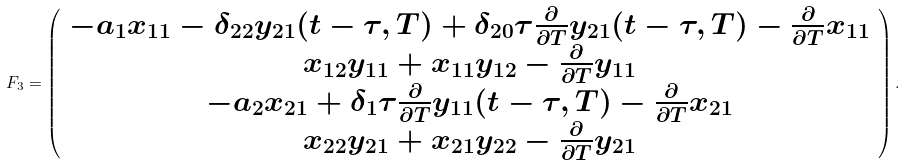Convert formula to latex. <formula><loc_0><loc_0><loc_500><loc_500>F _ { 3 } = \left ( \begin{array} { c } - a _ { 1 } x _ { 1 1 } - \delta _ { 2 2 } y _ { 2 1 } ( t - \tau , T ) + \delta _ { 2 0 } \tau \frac { \partial } { \partial T } y _ { 2 1 } ( t - \tau , T ) - \frac { \partial } { \partial T } x _ { 1 1 } \\ x _ { 1 2 } y _ { 1 1 } + x _ { 1 1 } y _ { 1 2 } - \frac { \partial } { \partial T } y _ { 1 1 } \\ - a _ { 2 } x _ { 2 1 } + \delta _ { 1 } \tau \frac { \partial } { \partial T } y _ { 1 1 } ( t - \tau , T ) - \frac { \partial } { \partial T } x _ { 2 1 } \\ x _ { 2 2 } y _ { 2 1 } + x _ { 2 1 } y _ { 2 2 } - \frac { \partial } { \partial T } y _ { 2 1 } \end{array} \right ) .</formula> 